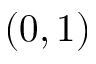Convert formula to latex. <formula><loc_0><loc_0><loc_500><loc_500>( 0 , 1 )</formula> 